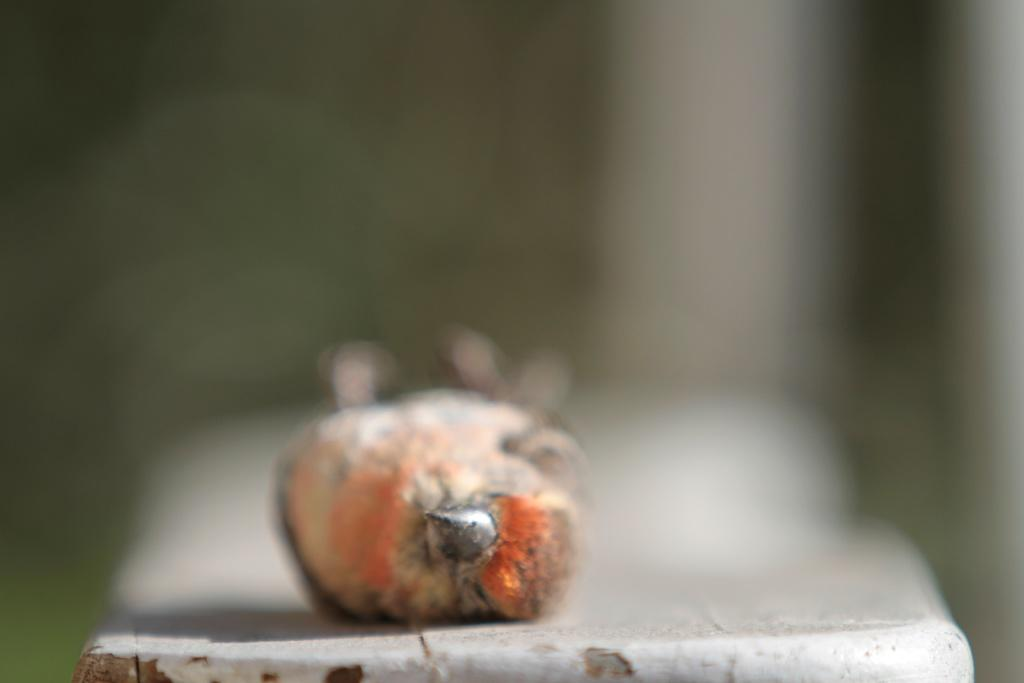What type of animal can be seen in the image? There is a bird in the image. What type of oatmeal is being served to the bird in the image? There is no oatmeal present in the image; it only features a bird. 